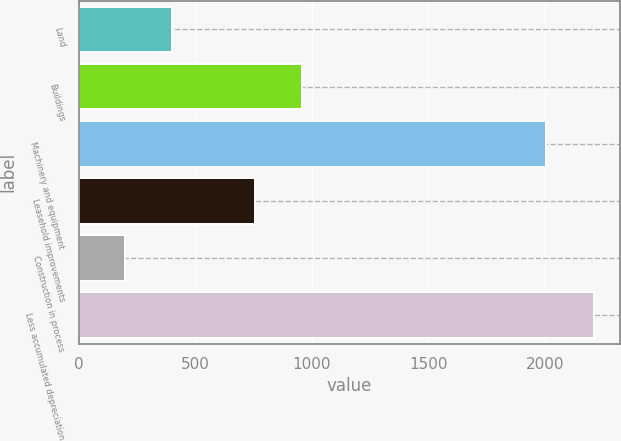Convert chart. <chart><loc_0><loc_0><loc_500><loc_500><bar_chart><fcel>Land<fcel>Buildings<fcel>Machinery and equipment<fcel>Leasehold improvements<fcel>Construction in process<fcel>Less accumulated depreciation<nl><fcel>398.22<fcel>958.82<fcel>2005<fcel>757.3<fcel>196.7<fcel>2211.9<nl></chart> 